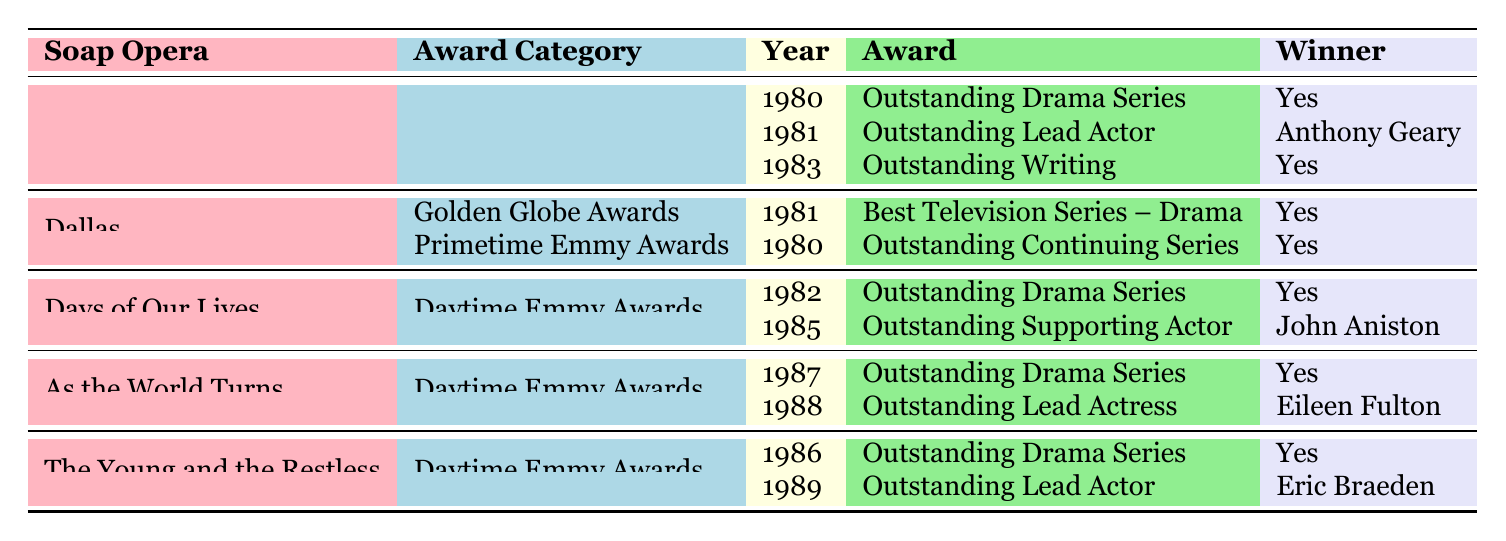What awards did General Hospital win in the 1980s? General Hospital won three awards during the 1980s: the Outstanding Drama Series at the Daytime Emmy Awards in 1980, the Outstanding Lead Actor award in 1981 for Anthony Geary, and the Outstanding Writing award in 1983, also at the Daytime Emmy Awards.
Answer: Three Which soap opera won the Best Television Series – Drama award? The soap opera Dallas won the Best Television Series – Drama award at the Golden Globe Awards in 1981.
Answer: Dallas How many soap operas won the Outstanding Drama Series award in the 1980s? The table lists three distinct instances of the Outstanding Drama Series award. General Hospital won it in 1980, Days of Our Lives in 1982, As the World Turns in 1987, and The Young and the Restless in 1986. Therefore, a total of four different soap operas won this award during the decade.
Answer: Four Did Days of Our Lives win more than one award during the 1980s? According to the table, Days of Our Lives won two awards: Outstanding Drama Series in 1982 and Outstanding Supporting Actor for John Aniston in 1985. Since the number is greater than one, the answer is yes.
Answer: Yes In what year did As the World Turns win its last award of the 1980s? As the World Turns won its last award of the decade in 1988 when Eileen Fulton received the Outstanding Lead Actress award at the Daytime Emmy Awards.
Answer: 1988 Which soap opera had an actor win the Outstanding Lead Actor award in 1981? From the table, we see that General Hospital had Anthony Geary win the Outstanding Lead Actor award in 1981.
Answer: General Hospital How many soap operas won at least one Daytime Emmy Award? Four soap operas—General Hospital, Days of Our Lives, As the World Turns, and The Young and the Restless—won at least one Daytime Emmy Award during the 1980s. Hence, we count these four distinct titles.
Answer: Four What is the relationship between the year and the awarded soap operas? Looking at each soap opera operated within various years, if we examine the awards' years closely, we can see a range from 1980 to 1989, indicating that soap operas were consistently recognized every few years during this decade.
Answer: Consistent recognition How many total awards for Outstanding Lead Actor were listed in the table? The table shows two Outstanding Lead Actor awards, one for Anthony Geary from General Hospital in 1981 and another for Eric Braeden from The Young and the Restless in 1989. Therefore, the total awards for Outstanding Lead Actor is two.
Answer: Two 